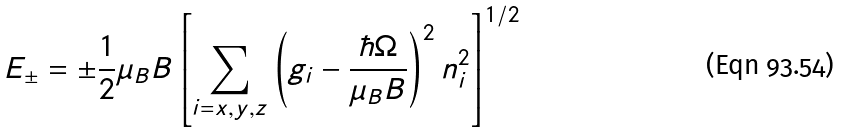Convert formula to latex. <formula><loc_0><loc_0><loc_500><loc_500>E _ { \pm } = \pm \frac { 1 } { 2 } \mu _ { B } B \left [ \sum _ { i = x , y , z } \left ( g _ { i } - \frac { \hbar { \Omega } } { \mu _ { B } B } \right ) ^ { 2 } n _ { i } ^ { 2 } \right ] ^ { 1 / 2 } \,</formula> 